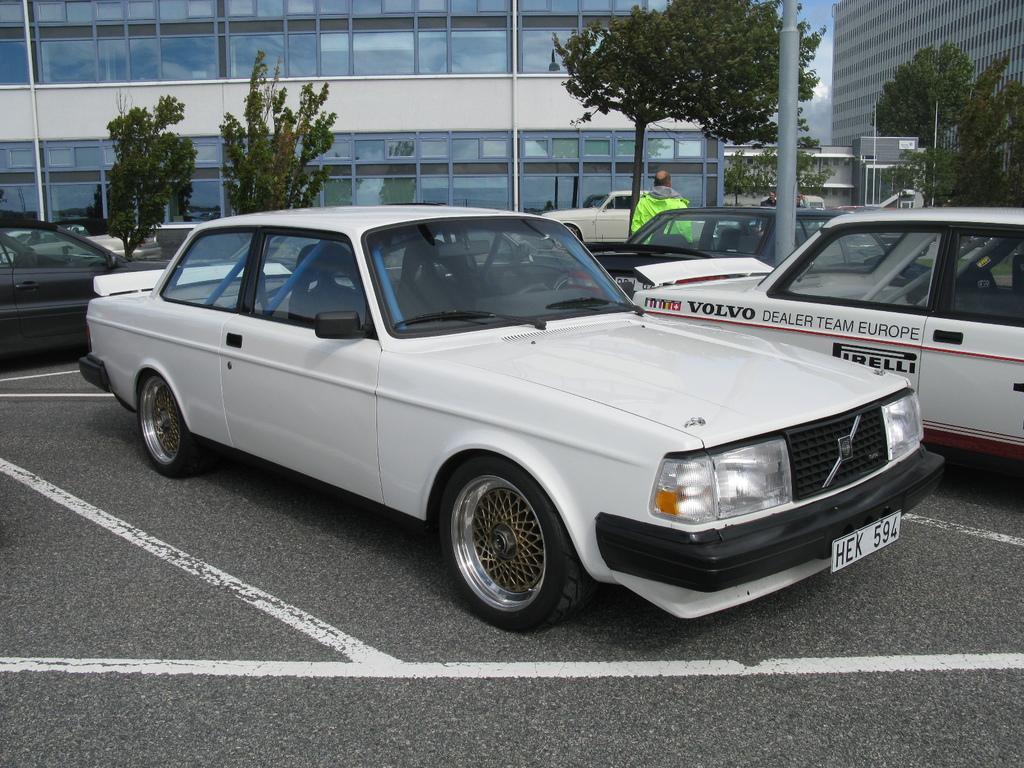Can you describe this image briefly? In this image I can see few vehicles and here on this vehicle I can see something is written. I can also see number of trees, few buildings and over here I can see a person is standing. I can also see white colour lines on road. 